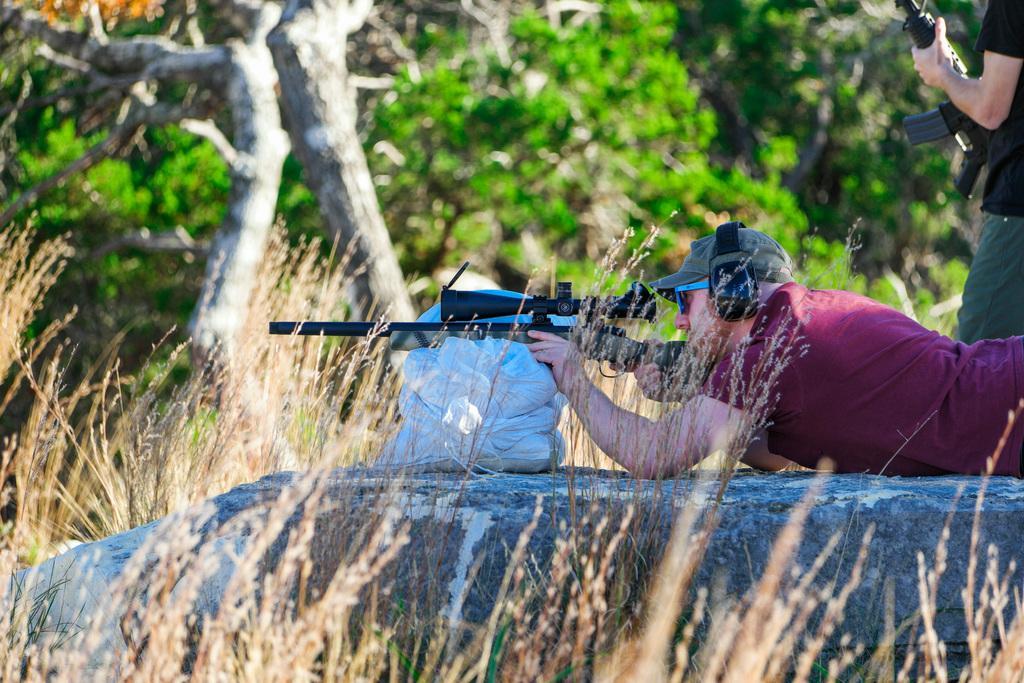How would you summarize this image in a sentence or two? In this picture we can see persons,they are holding guns and in the background we can see trees. 